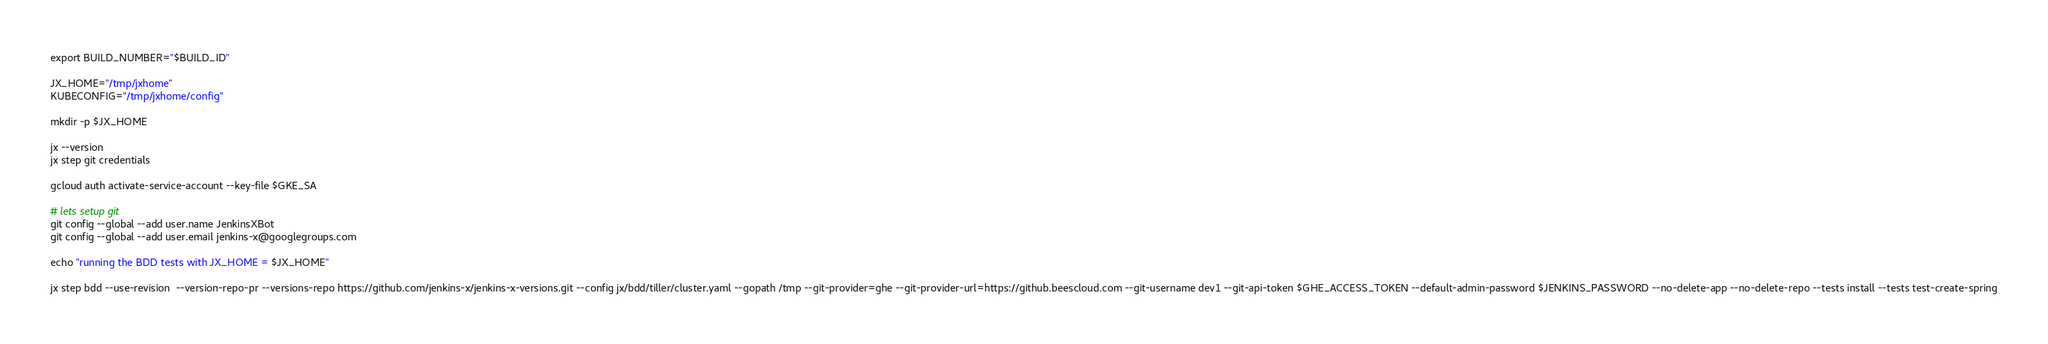Convert code to text. <code><loc_0><loc_0><loc_500><loc_500><_Bash_>export BUILD_NUMBER="$BUILD_ID"

JX_HOME="/tmp/jxhome"
KUBECONFIG="/tmp/jxhome/config"

mkdir -p $JX_HOME

jx --version
jx step git credentials

gcloud auth activate-service-account --key-file $GKE_SA

# lets setup git 
git config --global --add user.name JenkinsXBot
git config --global --add user.email jenkins-x@googlegroups.com

echo "running the BDD tests with JX_HOME = $JX_HOME"

jx step bdd --use-revision  --version-repo-pr --versions-repo https://github.com/jenkins-x/jenkins-x-versions.git --config jx/bdd/tiller/cluster.yaml --gopath /tmp --git-provider=ghe --git-provider-url=https://github.beescloud.com --git-username dev1 --git-api-token $GHE_ACCESS_TOKEN --default-admin-password $JENKINS_PASSWORD --no-delete-app --no-delete-repo --tests install --tests test-create-spring
</code> 